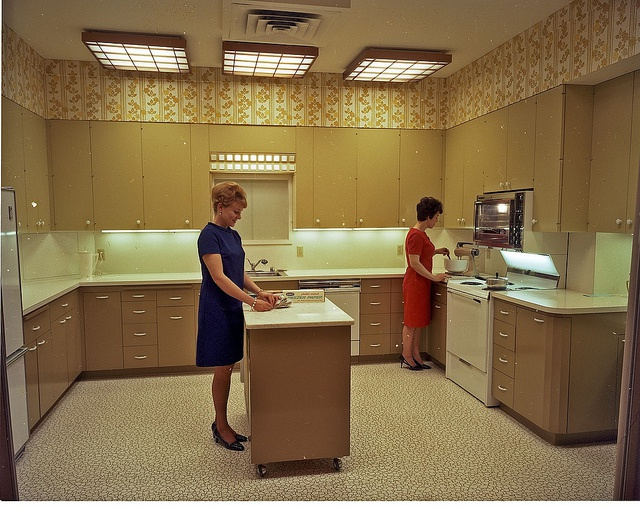Describe the objects in this image and their specific colors. I can see people in ivory, black, maroon, and brown tones, oven in ivory, tan, white, and gray tones, people in ivory, maroon, black, and brown tones, refrigerator in ivory, gray, and black tones, and bowl in ivory, tan, gray, and darkgray tones in this image. 